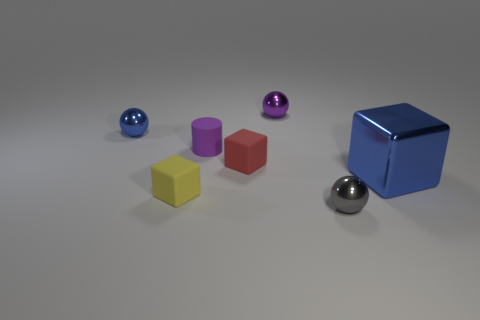Are there any other things that have the same shape as the tiny purple rubber object?
Your answer should be very brief. No. What is the shape of the large blue object?
Ensure brevity in your answer.  Cube. Are there more gray metallic objects behind the tiny purple sphere than things behind the large object?
Keep it short and to the point. No. There is a tiny metallic object to the left of the purple ball; is it the same color as the cube that is right of the red rubber block?
Provide a succinct answer. Yes. The red object that is the same size as the purple metal ball is what shape?
Make the answer very short. Cube. Are there any other things of the same shape as the yellow object?
Provide a short and direct response. Yes. Do the block that is behind the big blue metal thing and the small sphere in front of the tiny red cube have the same material?
Ensure brevity in your answer.  No. There is a tiny thing that is the same color as the tiny matte cylinder; what is its shape?
Ensure brevity in your answer.  Sphere. How many tiny purple cylinders have the same material as the small purple ball?
Your answer should be compact. 0. What is the color of the big block?
Ensure brevity in your answer.  Blue. 